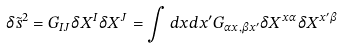<formula> <loc_0><loc_0><loc_500><loc_500>\delta \tilde { s } ^ { 2 } = G _ { I J } \delta X ^ { I } \delta X ^ { J } = \int d x d x ^ { \prime } G _ { \alpha x , \beta x ^ { \prime } } \delta X ^ { x \alpha } \delta X ^ { x ^ { \prime } \beta }</formula> 